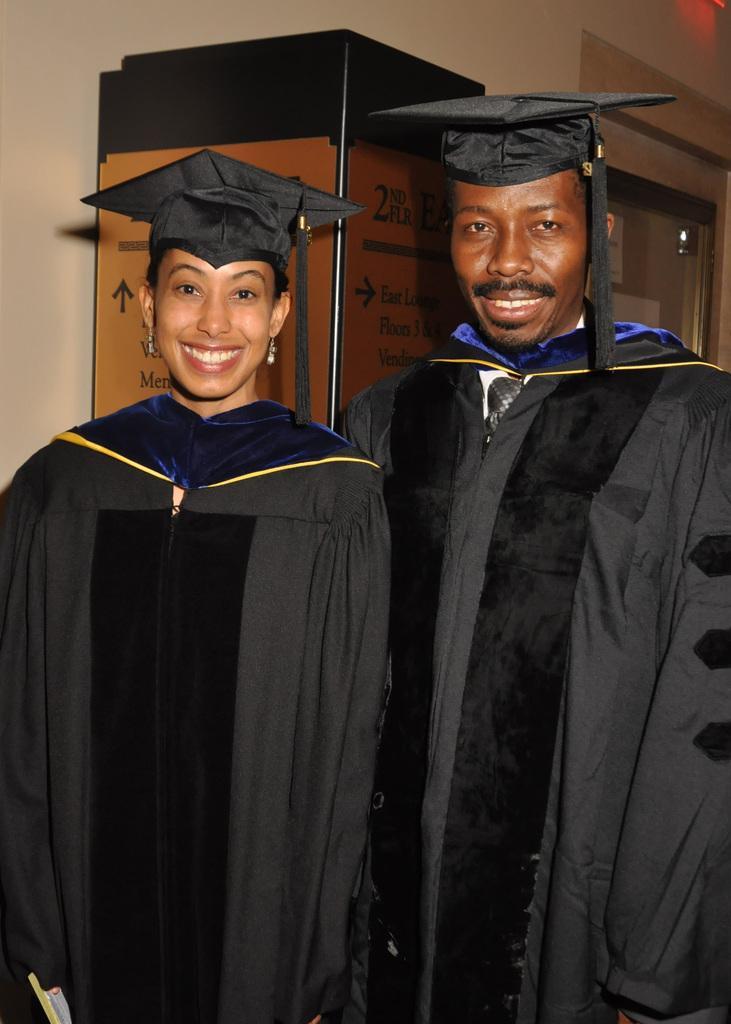How would you summarize this image in a sentence or two? In this picture there is a man and woman standing in front wearing black color convocation dress, smiling and giving a pose to the camera. Behind there is a brown cardboard and white wall. 